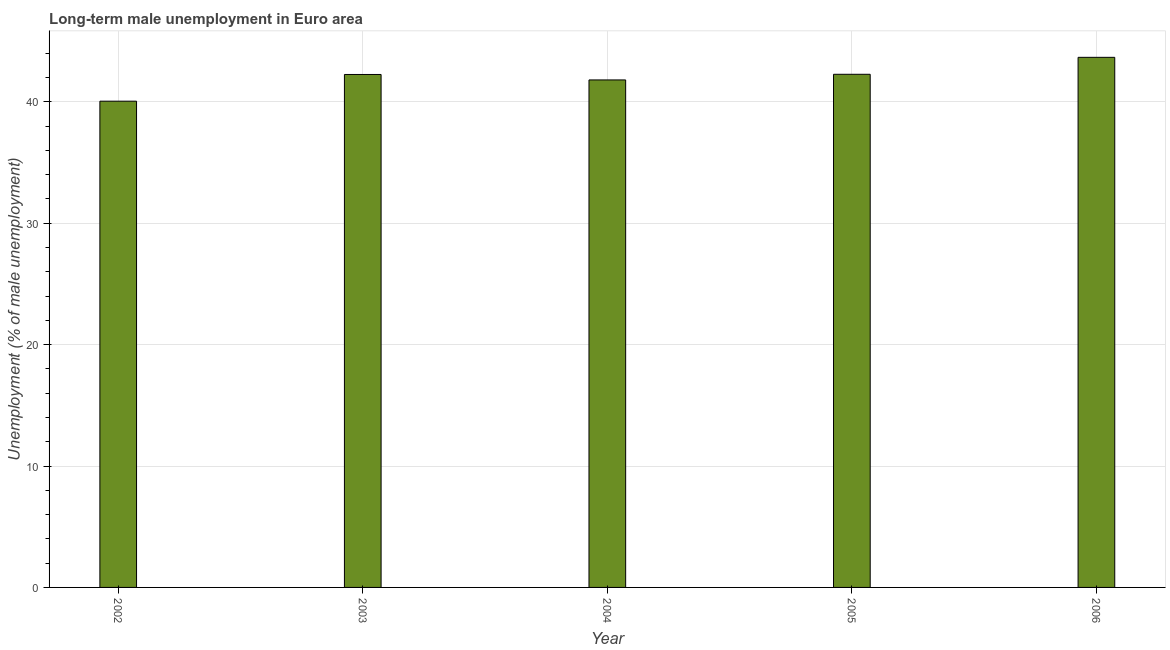What is the title of the graph?
Give a very brief answer. Long-term male unemployment in Euro area. What is the label or title of the Y-axis?
Your response must be concise. Unemployment (% of male unemployment). What is the long-term male unemployment in 2004?
Offer a very short reply. 41.8. Across all years, what is the maximum long-term male unemployment?
Your answer should be very brief. 43.67. Across all years, what is the minimum long-term male unemployment?
Your response must be concise. 40.05. In which year was the long-term male unemployment maximum?
Keep it short and to the point. 2006. In which year was the long-term male unemployment minimum?
Your answer should be very brief. 2002. What is the sum of the long-term male unemployment?
Give a very brief answer. 210.05. What is the difference between the long-term male unemployment in 2002 and 2005?
Your response must be concise. -2.21. What is the average long-term male unemployment per year?
Ensure brevity in your answer.  42.01. What is the median long-term male unemployment?
Make the answer very short. 42.25. Do a majority of the years between 2004 and 2005 (inclusive) have long-term male unemployment greater than 36 %?
Offer a very short reply. Yes. What is the ratio of the long-term male unemployment in 2003 to that in 2004?
Your response must be concise. 1.01. What is the difference between the highest and the second highest long-term male unemployment?
Ensure brevity in your answer.  1.4. What is the difference between the highest and the lowest long-term male unemployment?
Keep it short and to the point. 3.61. How many bars are there?
Your answer should be very brief. 5. Are all the bars in the graph horizontal?
Ensure brevity in your answer.  No. What is the Unemployment (% of male unemployment) in 2002?
Your answer should be compact. 40.05. What is the Unemployment (% of male unemployment) in 2003?
Ensure brevity in your answer.  42.25. What is the Unemployment (% of male unemployment) in 2004?
Your answer should be very brief. 41.8. What is the Unemployment (% of male unemployment) of 2005?
Provide a short and direct response. 42.27. What is the Unemployment (% of male unemployment) of 2006?
Provide a short and direct response. 43.67. What is the difference between the Unemployment (% of male unemployment) in 2002 and 2003?
Your answer should be very brief. -2.2. What is the difference between the Unemployment (% of male unemployment) in 2002 and 2004?
Your response must be concise. -1.75. What is the difference between the Unemployment (% of male unemployment) in 2002 and 2005?
Your answer should be very brief. -2.21. What is the difference between the Unemployment (% of male unemployment) in 2002 and 2006?
Make the answer very short. -3.61. What is the difference between the Unemployment (% of male unemployment) in 2003 and 2004?
Your answer should be compact. 0.45. What is the difference between the Unemployment (% of male unemployment) in 2003 and 2005?
Your response must be concise. -0.01. What is the difference between the Unemployment (% of male unemployment) in 2003 and 2006?
Offer a very short reply. -1.41. What is the difference between the Unemployment (% of male unemployment) in 2004 and 2005?
Offer a terse response. -0.46. What is the difference between the Unemployment (% of male unemployment) in 2004 and 2006?
Ensure brevity in your answer.  -1.86. What is the difference between the Unemployment (% of male unemployment) in 2005 and 2006?
Provide a succinct answer. -1.4. What is the ratio of the Unemployment (% of male unemployment) in 2002 to that in 2003?
Offer a terse response. 0.95. What is the ratio of the Unemployment (% of male unemployment) in 2002 to that in 2004?
Provide a succinct answer. 0.96. What is the ratio of the Unemployment (% of male unemployment) in 2002 to that in 2005?
Your response must be concise. 0.95. What is the ratio of the Unemployment (% of male unemployment) in 2002 to that in 2006?
Ensure brevity in your answer.  0.92. What is the ratio of the Unemployment (% of male unemployment) in 2003 to that in 2004?
Give a very brief answer. 1.01. What is the ratio of the Unemployment (% of male unemployment) in 2003 to that in 2005?
Your answer should be compact. 1. What is the ratio of the Unemployment (% of male unemployment) in 2003 to that in 2006?
Provide a succinct answer. 0.97. What is the ratio of the Unemployment (% of male unemployment) in 2004 to that in 2005?
Your response must be concise. 0.99. What is the ratio of the Unemployment (% of male unemployment) in 2005 to that in 2006?
Offer a terse response. 0.97. 